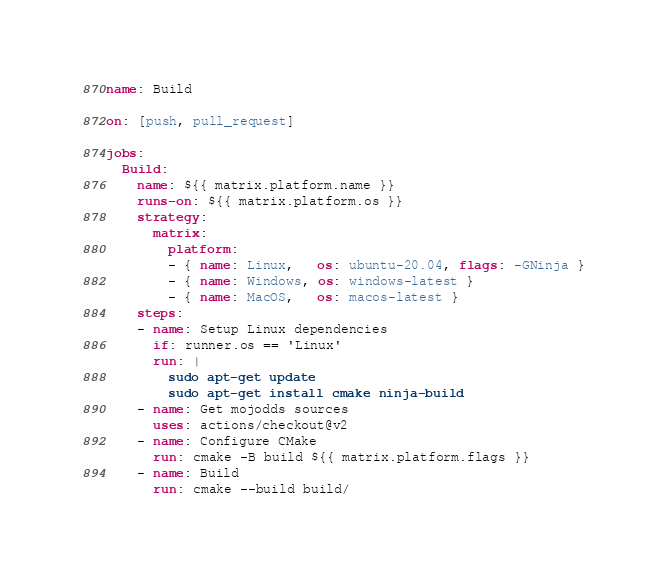<code> <loc_0><loc_0><loc_500><loc_500><_YAML_>name: Build

on: [push, pull_request]

jobs:
  Build:
    name: ${{ matrix.platform.name }}
    runs-on: ${{ matrix.platform.os }}
    strategy:
      matrix:
        platform:
        - { name: Linux,   os: ubuntu-20.04, flags: -GNinja }
        - { name: Windows, os: windows-latest }
        - { name: MacOS,   os: macos-latest }
    steps:
    - name: Setup Linux dependencies
      if: runner.os == 'Linux'
      run: |
        sudo apt-get update
        sudo apt-get install cmake ninja-build
    - name: Get mojodds sources
      uses: actions/checkout@v2
    - name: Configure CMake
      run: cmake -B build ${{ matrix.platform.flags }}
    - name: Build
      run: cmake --build build/
</code> 